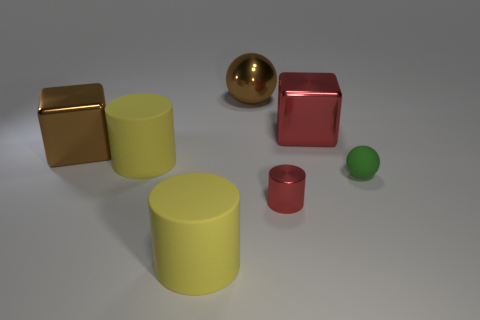Is the number of big brown cubes less than the number of yellow cylinders?
Provide a succinct answer. Yes. What material is the red cylinder right of the big metallic thing on the left side of the brown metallic thing right of the brown metallic block made of?
Your answer should be compact. Metal. Is the material of the brown object that is behind the big brown metal cube the same as the yellow object in front of the tiny ball?
Offer a terse response. No. There is a object that is on the right side of the brown ball and to the left of the big red metallic thing; how big is it?
Make the answer very short. Small. There is a brown ball that is the same size as the red metal block; what material is it?
Your response must be concise. Metal. There is a large metal block to the left of the large object in front of the matte ball; what number of tiny green spheres are behind it?
Offer a terse response. 0. There is a large thing on the right side of the big ball; is it the same color as the tiny object that is left of the big red metal thing?
Offer a terse response. Yes. There is a matte thing that is to the left of the tiny ball and behind the tiny metal cylinder; what color is it?
Your response must be concise. Yellow. How many red shiny cubes have the same size as the red cylinder?
Provide a short and direct response. 0. There is a yellow matte thing on the right side of the cylinder that is behind the small green matte ball; what is its shape?
Provide a short and direct response. Cylinder. 